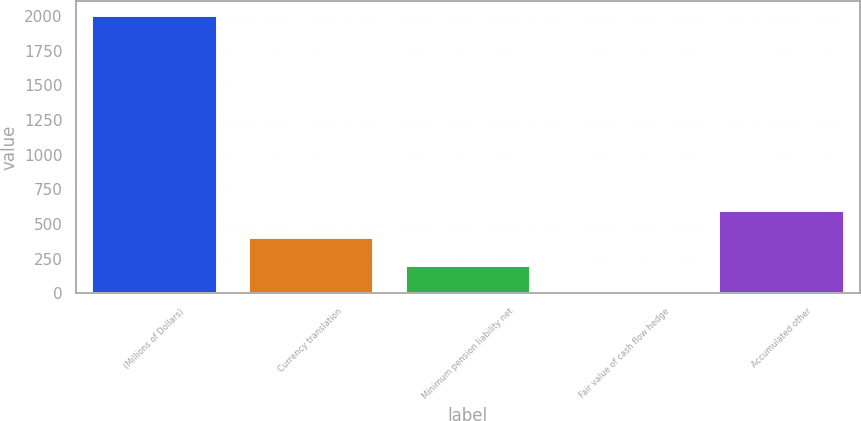<chart> <loc_0><loc_0><loc_500><loc_500><bar_chart><fcel>(Millions of Dollars)<fcel>Currency translation<fcel>Minimum pension liability net<fcel>Fair value of cash flow hedge<fcel>Accumulated other<nl><fcel>2005<fcel>404.28<fcel>204.19<fcel>4.1<fcel>604.37<nl></chart> 